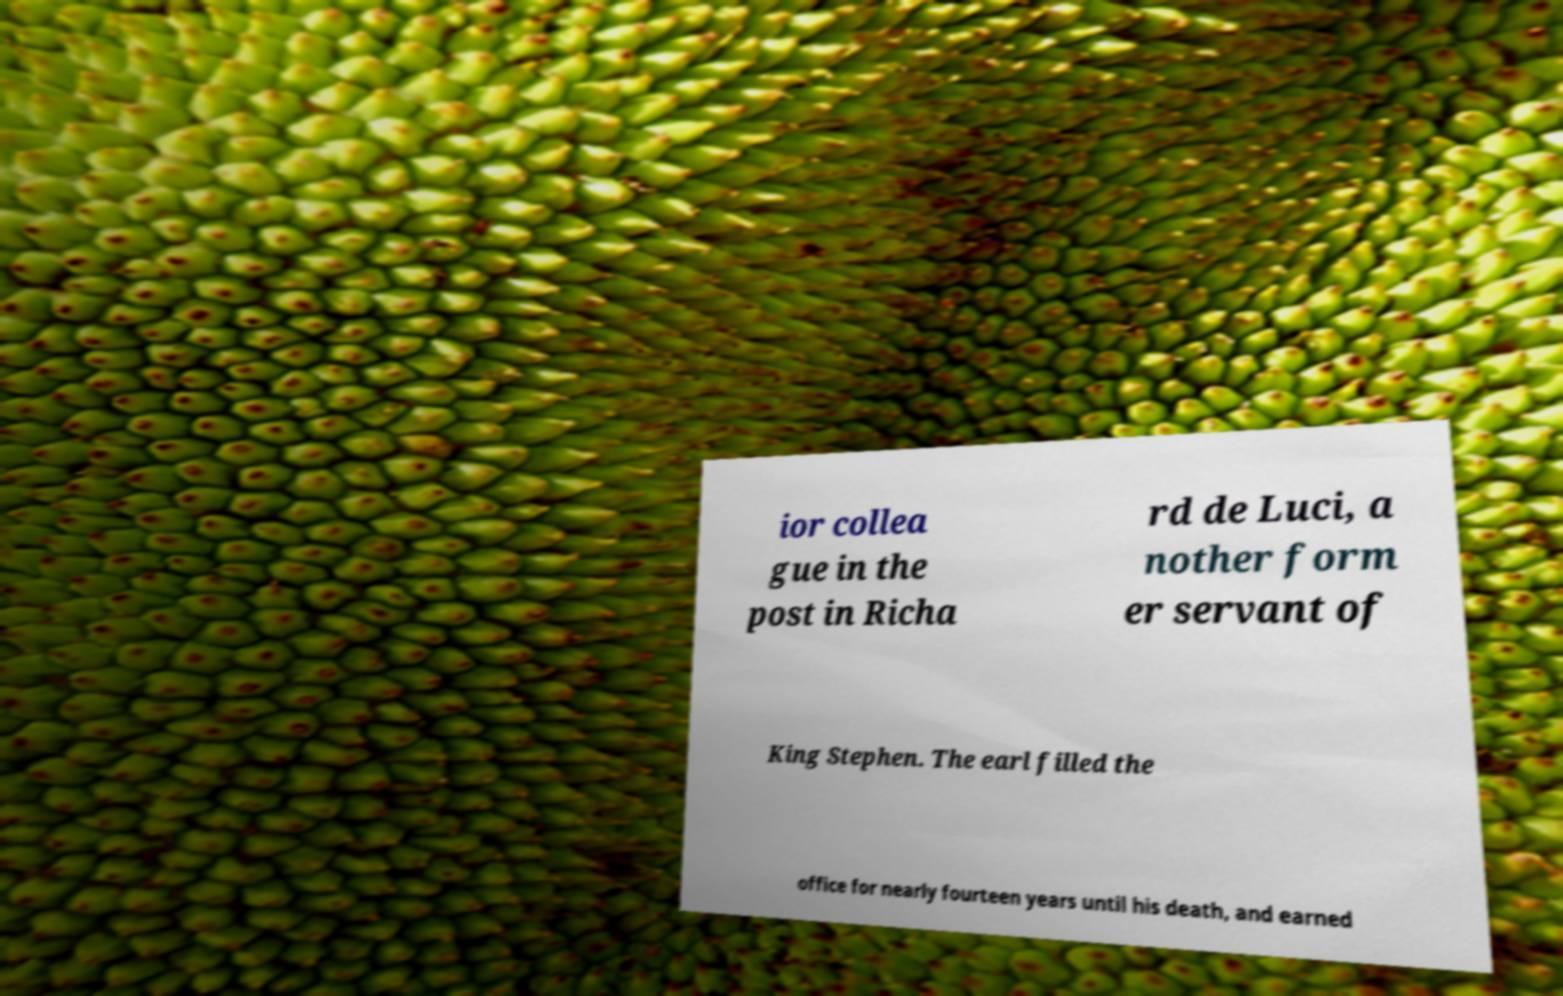I need the written content from this picture converted into text. Can you do that? ior collea gue in the post in Richa rd de Luci, a nother form er servant of King Stephen. The earl filled the office for nearly fourteen years until his death, and earned 